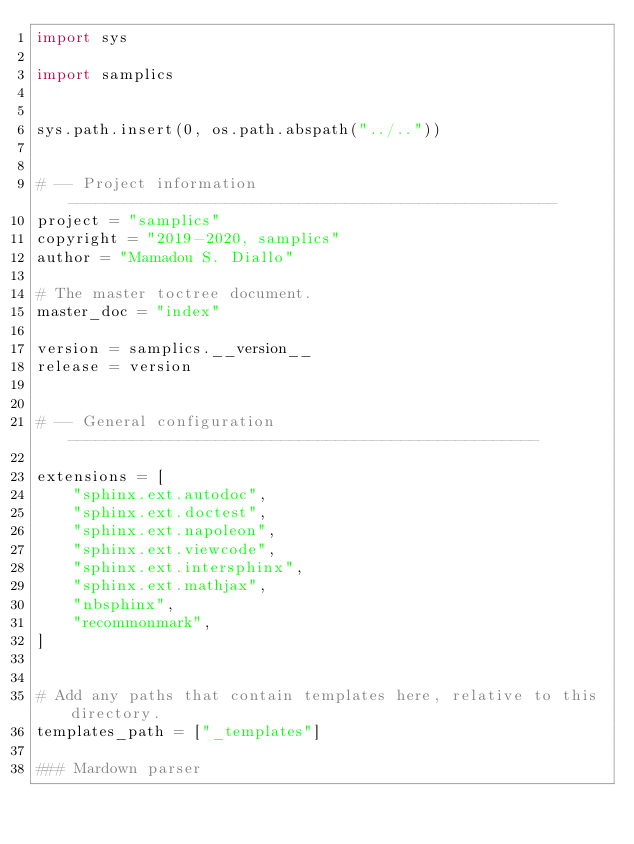<code> <loc_0><loc_0><loc_500><loc_500><_Python_>import sys

import samplics


sys.path.insert(0, os.path.abspath("../.."))


# -- Project information -----------------------------------------------------
project = "samplics"
copyright = "2019-2020, samplics"
author = "Mamadou S. Diallo"

# The master toctree document.
master_doc = "index"

version = samplics.__version__
release = version


# -- General configuration ---------------------------------------------------

extensions = [
    "sphinx.ext.autodoc",
    "sphinx.ext.doctest",
    "sphinx.ext.napoleon",
    "sphinx.ext.viewcode",
    "sphinx.ext.intersphinx",
    "sphinx.ext.mathjax",
    "nbsphinx",
    "recommonmark",
]


# Add any paths that contain templates here, relative to this directory.
templates_path = ["_templates"]

### Mardown parser</code> 